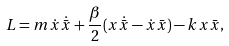<formula> <loc_0><loc_0><loc_500><loc_500>L = m \dot { x } \dot { \bar { x } } + \frac { \beta } { 2 } ( x \dot { \bar { x } } - \dot { x } \bar { x } ) - k x \bar { x } ,</formula> 